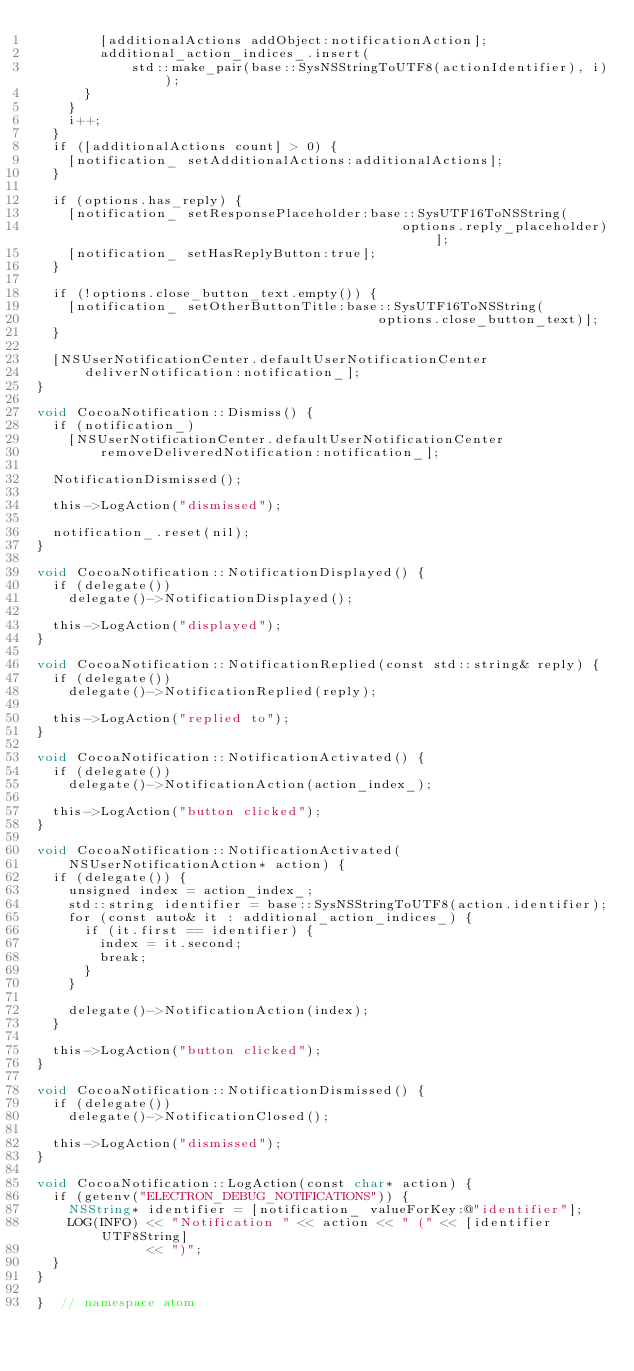<code> <loc_0><loc_0><loc_500><loc_500><_ObjectiveC_>        [additionalActions addObject:notificationAction];
        additional_action_indices_.insert(
            std::make_pair(base::SysNSStringToUTF8(actionIdentifier), i));
      }
    }
    i++;
  }
  if ([additionalActions count] > 0) {
    [notification_ setAdditionalActions:additionalActions];
  }

  if (options.has_reply) {
    [notification_ setResponsePlaceholder:base::SysUTF16ToNSString(
                                              options.reply_placeholder)];
    [notification_ setHasReplyButton:true];
  }

  if (!options.close_button_text.empty()) {
    [notification_ setOtherButtonTitle:base::SysUTF16ToNSString(
                                           options.close_button_text)];
  }

  [NSUserNotificationCenter.defaultUserNotificationCenter
      deliverNotification:notification_];
}

void CocoaNotification::Dismiss() {
  if (notification_)
    [NSUserNotificationCenter.defaultUserNotificationCenter
        removeDeliveredNotification:notification_];

  NotificationDismissed();

  this->LogAction("dismissed");

  notification_.reset(nil);
}

void CocoaNotification::NotificationDisplayed() {
  if (delegate())
    delegate()->NotificationDisplayed();

  this->LogAction("displayed");
}

void CocoaNotification::NotificationReplied(const std::string& reply) {
  if (delegate())
    delegate()->NotificationReplied(reply);

  this->LogAction("replied to");
}

void CocoaNotification::NotificationActivated() {
  if (delegate())
    delegate()->NotificationAction(action_index_);

  this->LogAction("button clicked");
}

void CocoaNotification::NotificationActivated(
    NSUserNotificationAction* action) {
  if (delegate()) {
    unsigned index = action_index_;
    std::string identifier = base::SysNSStringToUTF8(action.identifier);
    for (const auto& it : additional_action_indices_) {
      if (it.first == identifier) {
        index = it.second;
        break;
      }
    }

    delegate()->NotificationAction(index);
  }

  this->LogAction("button clicked");
}

void CocoaNotification::NotificationDismissed() {
  if (delegate())
    delegate()->NotificationClosed();

  this->LogAction("dismissed");
}

void CocoaNotification::LogAction(const char* action) {
  if (getenv("ELECTRON_DEBUG_NOTIFICATIONS")) {
    NSString* identifier = [notification_ valueForKey:@"identifier"];
    LOG(INFO) << "Notification " << action << " (" << [identifier UTF8String]
              << ")";
  }
}

}  // namespace atom
</code> 